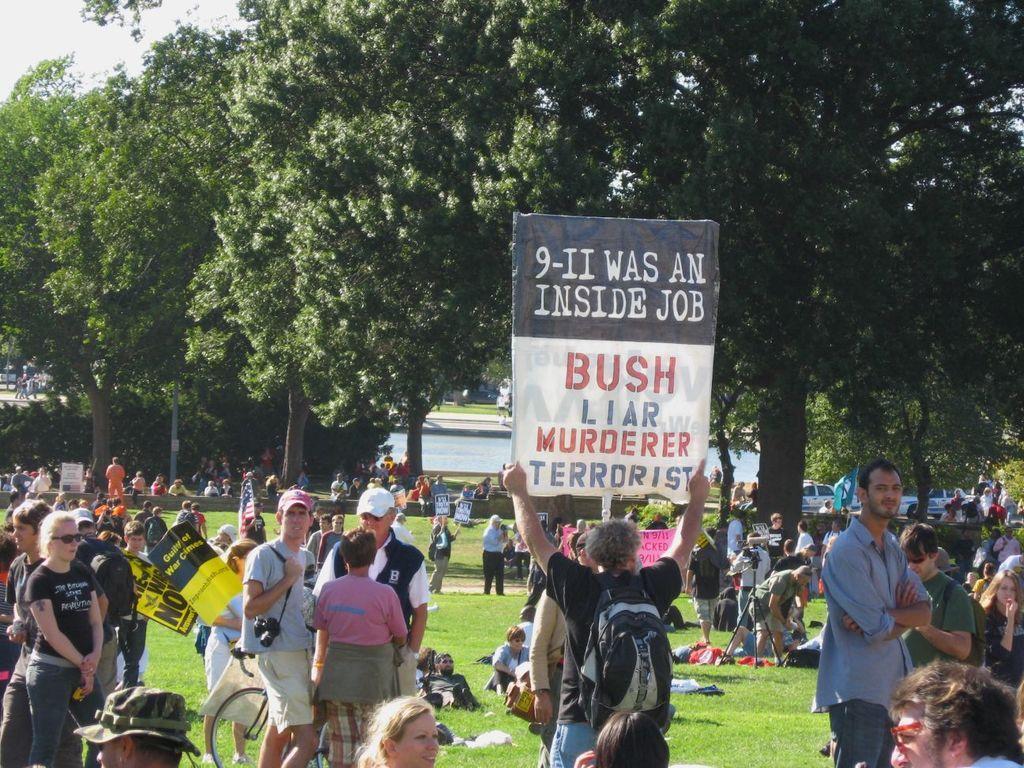How would you summarize this image in a sentence or two? In this image there are many people standing and many people sitting on the ground. There is grass on the ground. There are people holding placards in their hands. Behind them there are trees and plants on the ground. In the background there is the water. To the right there are cars parked on the ground. In the center there is a man holding a placard in his hands. There is text on the placard. In the top left there is the sky. 